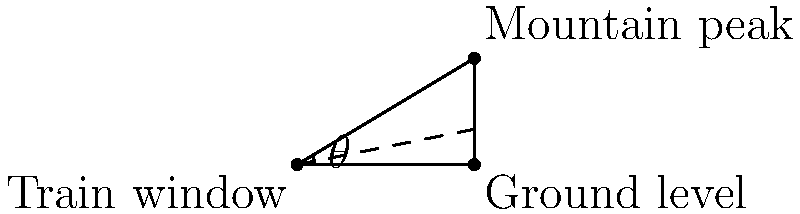A scenic mountain is visible from a train window. The angle of elevation to the mountain peak is 31°. If the mountain peak is 3000 meters above the ground level and the train tracks are horizontal, how far is the train from the base of the mountain? To solve this problem, we'll use trigonometry:

1) Let's define our variables:
   $\theta$ = angle of elevation = 31°
   $h$ = height of the mountain = 3000 meters
   $d$ = distance from the train to the base of the mountain (what we're solving for)

2) In this scenario, we have a right triangle where:
   - The adjacent side is the distance $d$
   - The opposite side is the height $h$
   - The angle at the train window is $\theta$

3) We can use the tangent function, which is defined as:

   $\tan(\theta) = \frac{\text{opposite}}{\text{adjacent}} = \frac{h}{d}$

4) Substituting our known values:

   $\tan(31°) = \frac{3000}{d}$

5) To solve for $d$, we multiply both sides by $d$:

   $d \cdot \tan(31°) = 3000$

6) Then divide both sides by $\tan(31°)$:

   $d = \frac{3000}{\tan(31°)}$

7) Using a calculator (or trigonometric tables):

   $d \approx 4989.76$ meters

8) Rounding to the nearest meter:

   $d \approx 4990$ meters
Answer: 4990 meters 